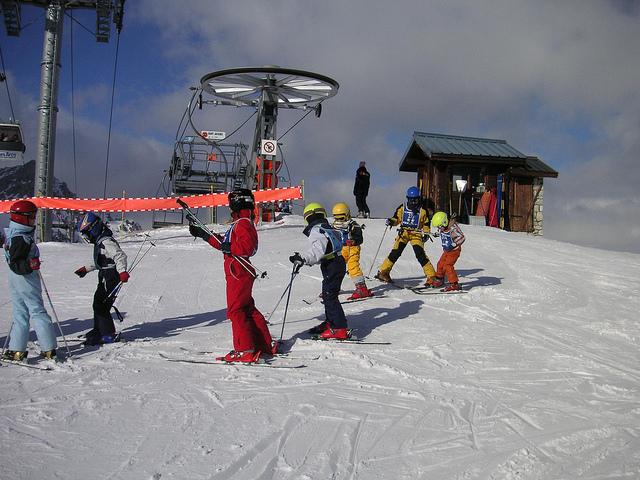Is the snow deep?
Short answer required. No. Are they skiing?
Concise answer only. Yes. How many people are in the picture?
Quick response, please. 8. 